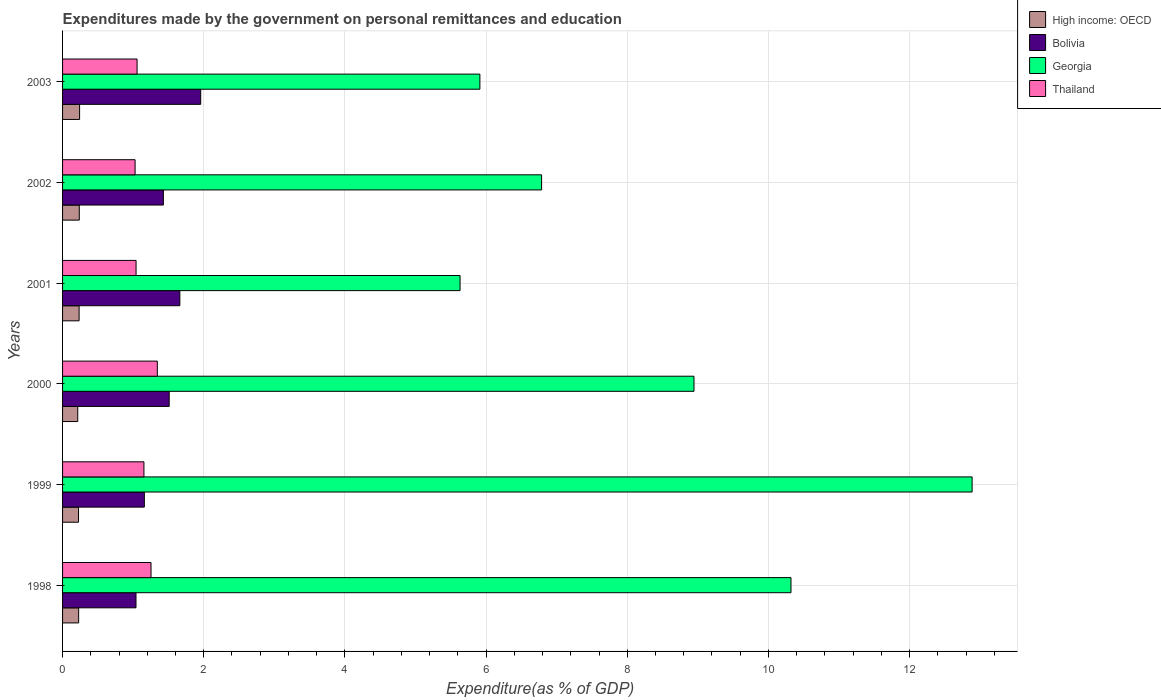How many groups of bars are there?
Make the answer very short. 6. Are the number of bars per tick equal to the number of legend labels?
Provide a succinct answer. Yes. How many bars are there on the 1st tick from the top?
Offer a very short reply. 4. How many bars are there on the 2nd tick from the bottom?
Your answer should be compact. 4. What is the label of the 4th group of bars from the top?
Provide a short and direct response. 2000. In how many cases, is the number of bars for a given year not equal to the number of legend labels?
Your answer should be very brief. 0. What is the expenditures made by the government on personal remittances and education in Bolivia in 2001?
Offer a terse response. 1.66. Across all years, what is the maximum expenditures made by the government on personal remittances and education in Georgia?
Provide a succinct answer. 12.89. Across all years, what is the minimum expenditures made by the government on personal remittances and education in Thailand?
Your answer should be very brief. 1.03. In which year was the expenditures made by the government on personal remittances and education in Bolivia maximum?
Offer a very short reply. 2003. What is the total expenditures made by the government on personal remittances and education in Bolivia in the graph?
Offer a very short reply. 8.76. What is the difference between the expenditures made by the government on personal remittances and education in Georgia in 1998 and that in 2001?
Provide a short and direct response. 4.69. What is the difference between the expenditures made by the government on personal remittances and education in High income: OECD in 2000 and the expenditures made by the government on personal remittances and education in Thailand in 1998?
Offer a terse response. -1.04. What is the average expenditures made by the government on personal remittances and education in Thailand per year?
Your response must be concise. 1.15. In the year 1999, what is the difference between the expenditures made by the government on personal remittances and education in Bolivia and expenditures made by the government on personal remittances and education in High income: OECD?
Your answer should be compact. 0.93. What is the ratio of the expenditures made by the government on personal remittances and education in Georgia in 2002 to that in 2003?
Provide a succinct answer. 1.15. Is the difference between the expenditures made by the government on personal remittances and education in Bolivia in 1998 and 1999 greater than the difference between the expenditures made by the government on personal remittances and education in High income: OECD in 1998 and 1999?
Ensure brevity in your answer.  No. What is the difference between the highest and the second highest expenditures made by the government on personal remittances and education in Georgia?
Ensure brevity in your answer.  2.57. What is the difference between the highest and the lowest expenditures made by the government on personal remittances and education in High income: OECD?
Your answer should be compact. 0.03. Is it the case that in every year, the sum of the expenditures made by the government on personal remittances and education in Thailand and expenditures made by the government on personal remittances and education in High income: OECD is greater than the sum of expenditures made by the government on personal remittances and education in Bolivia and expenditures made by the government on personal remittances and education in Georgia?
Ensure brevity in your answer.  Yes. What does the 3rd bar from the top in 2001 represents?
Offer a terse response. Bolivia. What does the 2nd bar from the bottom in 2000 represents?
Offer a terse response. Bolivia. How many bars are there?
Your answer should be very brief. 24. Are all the bars in the graph horizontal?
Offer a terse response. Yes. How many years are there in the graph?
Offer a very short reply. 6. What is the difference between two consecutive major ticks on the X-axis?
Your answer should be compact. 2. Are the values on the major ticks of X-axis written in scientific E-notation?
Ensure brevity in your answer.  No. Does the graph contain any zero values?
Keep it short and to the point. No. How are the legend labels stacked?
Your answer should be very brief. Vertical. What is the title of the graph?
Ensure brevity in your answer.  Expenditures made by the government on personal remittances and education. What is the label or title of the X-axis?
Offer a very short reply. Expenditure(as % of GDP). What is the Expenditure(as % of GDP) in High income: OECD in 1998?
Offer a terse response. 0.23. What is the Expenditure(as % of GDP) in Bolivia in 1998?
Give a very brief answer. 1.04. What is the Expenditure(as % of GDP) in Georgia in 1998?
Your response must be concise. 10.32. What is the Expenditure(as % of GDP) of Thailand in 1998?
Your answer should be very brief. 1.25. What is the Expenditure(as % of GDP) of High income: OECD in 1999?
Offer a terse response. 0.23. What is the Expenditure(as % of GDP) in Bolivia in 1999?
Make the answer very short. 1.16. What is the Expenditure(as % of GDP) in Georgia in 1999?
Your answer should be very brief. 12.89. What is the Expenditure(as % of GDP) of Thailand in 1999?
Your answer should be compact. 1.15. What is the Expenditure(as % of GDP) of High income: OECD in 2000?
Make the answer very short. 0.22. What is the Expenditure(as % of GDP) of Bolivia in 2000?
Offer a terse response. 1.51. What is the Expenditure(as % of GDP) of Georgia in 2000?
Provide a succinct answer. 8.95. What is the Expenditure(as % of GDP) of Thailand in 2000?
Provide a short and direct response. 1.34. What is the Expenditure(as % of GDP) of High income: OECD in 2001?
Keep it short and to the point. 0.23. What is the Expenditure(as % of GDP) in Bolivia in 2001?
Make the answer very short. 1.66. What is the Expenditure(as % of GDP) in Georgia in 2001?
Ensure brevity in your answer.  5.63. What is the Expenditure(as % of GDP) of Thailand in 2001?
Your answer should be compact. 1.04. What is the Expenditure(as % of GDP) in High income: OECD in 2002?
Offer a terse response. 0.24. What is the Expenditure(as % of GDP) of Bolivia in 2002?
Ensure brevity in your answer.  1.43. What is the Expenditure(as % of GDP) of Georgia in 2002?
Offer a very short reply. 6.79. What is the Expenditure(as % of GDP) of Thailand in 2002?
Provide a succinct answer. 1.03. What is the Expenditure(as % of GDP) of High income: OECD in 2003?
Your answer should be very brief. 0.24. What is the Expenditure(as % of GDP) of Bolivia in 2003?
Keep it short and to the point. 1.96. What is the Expenditure(as % of GDP) of Georgia in 2003?
Your answer should be compact. 5.91. What is the Expenditure(as % of GDP) in Thailand in 2003?
Your answer should be compact. 1.06. Across all years, what is the maximum Expenditure(as % of GDP) in High income: OECD?
Your answer should be very brief. 0.24. Across all years, what is the maximum Expenditure(as % of GDP) in Bolivia?
Your answer should be compact. 1.96. Across all years, what is the maximum Expenditure(as % of GDP) of Georgia?
Provide a succinct answer. 12.89. Across all years, what is the maximum Expenditure(as % of GDP) in Thailand?
Your response must be concise. 1.34. Across all years, what is the minimum Expenditure(as % of GDP) of High income: OECD?
Keep it short and to the point. 0.22. Across all years, what is the minimum Expenditure(as % of GDP) in Bolivia?
Keep it short and to the point. 1.04. Across all years, what is the minimum Expenditure(as % of GDP) of Georgia?
Provide a short and direct response. 5.63. Across all years, what is the minimum Expenditure(as % of GDP) of Thailand?
Make the answer very short. 1.03. What is the total Expenditure(as % of GDP) of High income: OECD in the graph?
Provide a succinct answer. 1.38. What is the total Expenditure(as % of GDP) of Bolivia in the graph?
Ensure brevity in your answer.  8.76. What is the total Expenditure(as % of GDP) of Georgia in the graph?
Offer a very short reply. 50.48. What is the total Expenditure(as % of GDP) in Thailand in the graph?
Offer a terse response. 6.87. What is the difference between the Expenditure(as % of GDP) of High income: OECD in 1998 and that in 1999?
Offer a very short reply. 0. What is the difference between the Expenditure(as % of GDP) of Bolivia in 1998 and that in 1999?
Keep it short and to the point. -0.12. What is the difference between the Expenditure(as % of GDP) of Georgia in 1998 and that in 1999?
Your response must be concise. -2.57. What is the difference between the Expenditure(as % of GDP) in Thailand in 1998 and that in 1999?
Provide a short and direct response. 0.1. What is the difference between the Expenditure(as % of GDP) in High income: OECD in 1998 and that in 2000?
Keep it short and to the point. 0.01. What is the difference between the Expenditure(as % of GDP) in Bolivia in 1998 and that in 2000?
Provide a succinct answer. -0.47. What is the difference between the Expenditure(as % of GDP) in Georgia in 1998 and that in 2000?
Give a very brief answer. 1.37. What is the difference between the Expenditure(as % of GDP) of Thailand in 1998 and that in 2000?
Provide a short and direct response. -0.09. What is the difference between the Expenditure(as % of GDP) of High income: OECD in 1998 and that in 2001?
Provide a succinct answer. -0.01. What is the difference between the Expenditure(as % of GDP) of Bolivia in 1998 and that in 2001?
Offer a terse response. -0.62. What is the difference between the Expenditure(as % of GDP) in Georgia in 1998 and that in 2001?
Offer a terse response. 4.69. What is the difference between the Expenditure(as % of GDP) in Thailand in 1998 and that in 2001?
Provide a short and direct response. 0.21. What is the difference between the Expenditure(as % of GDP) of High income: OECD in 1998 and that in 2002?
Your answer should be compact. -0.01. What is the difference between the Expenditure(as % of GDP) in Bolivia in 1998 and that in 2002?
Ensure brevity in your answer.  -0.39. What is the difference between the Expenditure(as % of GDP) of Georgia in 1998 and that in 2002?
Provide a short and direct response. 3.53. What is the difference between the Expenditure(as % of GDP) of Thailand in 1998 and that in 2002?
Keep it short and to the point. 0.23. What is the difference between the Expenditure(as % of GDP) in High income: OECD in 1998 and that in 2003?
Provide a succinct answer. -0.01. What is the difference between the Expenditure(as % of GDP) of Bolivia in 1998 and that in 2003?
Ensure brevity in your answer.  -0.92. What is the difference between the Expenditure(as % of GDP) of Georgia in 1998 and that in 2003?
Offer a terse response. 4.41. What is the difference between the Expenditure(as % of GDP) in Thailand in 1998 and that in 2003?
Your answer should be very brief. 0.2. What is the difference between the Expenditure(as % of GDP) of High income: OECD in 1999 and that in 2000?
Offer a very short reply. 0.01. What is the difference between the Expenditure(as % of GDP) of Bolivia in 1999 and that in 2000?
Provide a short and direct response. -0.35. What is the difference between the Expenditure(as % of GDP) in Georgia in 1999 and that in 2000?
Offer a very short reply. 3.94. What is the difference between the Expenditure(as % of GDP) of Thailand in 1999 and that in 2000?
Keep it short and to the point. -0.19. What is the difference between the Expenditure(as % of GDP) of High income: OECD in 1999 and that in 2001?
Offer a terse response. -0.01. What is the difference between the Expenditure(as % of GDP) of Bolivia in 1999 and that in 2001?
Offer a very short reply. -0.5. What is the difference between the Expenditure(as % of GDP) in Georgia in 1999 and that in 2001?
Your answer should be very brief. 7.25. What is the difference between the Expenditure(as % of GDP) of Thailand in 1999 and that in 2001?
Your response must be concise. 0.11. What is the difference between the Expenditure(as % of GDP) of High income: OECD in 1999 and that in 2002?
Keep it short and to the point. -0.01. What is the difference between the Expenditure(as % of GDP) of Bolivia in 1999 and that in 2002?
Your answer should be compact. -0.27. What is the difference between the Expenditure(as % of GDP) in Georgia in 1999 and that in 2002?
Make the answer very short. 6.1. What is the difference between the Expenditure(as % of GDP) of Thailand in 1999 and that in 2002?
Your answer should be compact. 0.13. What is the difference between the Expenditure(as % of GDP) in High income: OECD in 1999 and that in 2003?
Offer a very short reply. -0.02. What is the difference between the Expenditure(as % of GDP) of Bolivia in 1999 and that in 2003?
Give a very brief answer. -0.8. What is the difference between the Expenditure(as % of GDP) in Georgia in 1999 and that in 2003?
Your response must be concise. 6.97. What is the difference between the Expenditure(as % of GDP) in Thailand in 1999 and that in 2003?
Your answer should be compact. 0.1. What is the difference between the Expenditure(as % of GDP) of High income: OECD in 2000 and that in 2001?
Make the answer very short. -0.02. What is the difference between the Expenditure(as % of GDP) in Bolivia in 2000 and that in 2001?
Ensure brevity in your answer.  -0.15. What is the difference between the Expenditure(as % of GDP) in Georgia in 2000 and that in 2001?
Your answer should be very brief. 3.31. What is the difference between the Expenditure(as % of GDP) of Thailand in 2000 and that in 2001?
Provide a short and direct response. 0.3. What is the difference between the Expenditure(as % of GDP) of High income: OECD in 2000 and that in 2002?
Your answer should be compact. -0.02. What is the difference between the Expenditure(as % of GDP) of Bolivia in 2000 and that in 2002?
Make the answer very short. 0.08. What is the difference between the Expenditure(as % of GDP) in Georgia in 2000 and that in 2002?
Keep it short and to the point. 2.16. What is the difference between the Expenditure(as % of GDP) of Thailand in 2000 and that in 2002?
Provide a short and direct response. 0.31. What is the difference between the Expenditure(as % of GDP) of High income: OECD in 2000 and that in 2003?
Provide a succinct answer. -0.03. What is the difference between the Expenditure(as % of GDP) in Bolivia in 2000 and that in 2003?
Ensure brevity in your answer.  -0.45. What is the difference between the Expenditure(as % of GDP) in Georgia in 2000 and that in 2003?
Make the answer very short. 3.03. What is the difference between the Expenditure(as % of GDP) of Thailand in 2000 and that in 2003?
Keep it short and to the point. 0.29. What is the difference between the Expenditure(as % of GDP) in High income: OECD in 2001 and that in 2002?
Give a very brief answer. -0. What is the difference between the Expenditure(as % of GDP) in Bolivia in 2001 and that in 2002?
Provide a short and direct response. 0.23. What is the difference between the Expenditure(as % of GDP) of Georgia in 2001 and that in 2002?
Ensure brevity in your answer.  -1.16. What is the difference between the Expenditure(as % of GDP) in Thailand in 2001 and that in 2002?
Ensure brevity in your answer.  0.01. What is the difference between the Expenditure(as % of GDP) of High income: OECD in 2001 and that in 2003?
Your answer should be compact. -0.01. What is the difference between the Expenditure(as % of GDP) in Bolivia in 2001 and that in 2003?
Make the answer very short. -0.3. What is the difference between the Expenditure(as % of GDP) of Georgia in 2001 and that in 2003?
Offer a terse response. -0.28. What is the difference between the Expenditure(as % of GDP) in Thailand in 2001 and that in 2003?
Offer a very short reply. -0.01. What is the difference between the Expenditure(as % of GDP) of High income: OECD in 2002 and that in 2003?
Provide a short and direct response. -0. What is the difference between the Expenditure(as % of GDP) of Bolivia in 2002 and that in 2003?
Give a very brief answer. -0.53. What is the difference between the Expenditure(as % of GDP) of Georgia in 2002 and that in 2003?
Offer a terse response. 0.87. What is the difference between the Expenditure(as % of GDP) in Thailand in 2002 and that in 2003?
Keep it short and to the point. -0.03. What is the difference between the Expenditure(as % of GDP) in High income: OECD in 1998 and the Expenditure(as % of GDP) in Bolivia in 1999?
Offer a terse response. -0.93. What is the difference between the Expenditure(as % of GDP) of High income: OECD in 1998 and the Expenditure(as % of GDP) of Georgia in 1999?
Give a very brief answer. -12.66. What is the difference between the Expenditure(as % of GDP) of High income: OECD in 1998 and the Expenditure(as % of GDP) of Thailand in 1999?
Provide a short and direct response. -0.93. What is the difference between the Expenditure(as % of GDP) in Bolivia in 1998 and the Expenditure(as % of GDP) in Georgia in 1999?
Provide a succinct answer. -11.85. What is the difference between the Expenditure(as % of GDP) of Bolivia in 1998 and the Expenditure(as % of GDP) of Thailand in 1999?
Offer a terse response. -0.11. What is the difference between the Expenditure(as % of GDP) of Georgia in 1998 and the Expenditure(as % of GDP) of Thailand in 1999?
Give a very brief answer. 9.17. What is the difference between the Expenditure(as % of GDP) of High income: OECD in 1998 and the Expenditure(as % of GDP) of Bolivia in 2000?
Your answer should be compact. -1.28. What is the difference between the Expenditure(as % of GDP) in High income: OECD in 1998 and the Expenditure(as % of GDP) in Georgia in 2000?
Keep it short and to the point. -8.72. What is the difference between the Expenditure(as % of GDP) of High income: OECD in 1998 and the Expenditure(as % of GDP) of Thailand in 2000?
Your response must be concise. -1.11. What is the difference between the Expenditure(as % of GDP) of Bolivia in 1998 and the Expenditure(as % of GDP) of Georgia in 2000?
Keep it short and to the point. -7.91. What is the difference between the Expenditure(as % of GDP) of Bolivia in 1998 and the Expenditure(as % of GDP) of Thailand in 2000?
Offer a terse response. -0.3. What is the difference between the Expenditure(as % of GDP) in Georgia in 1998 and the Expenditure(as % of GDP) in Thailand in 2000?
Offer a terse response. 8.98. What is the difference between the Expenditure(as % of GDP) in High income: OECD in 1998 and the Expenditure(as % of GDP) in Bolivia in 2001?
Your response must be concise. -1.43. What is the difference between the Expenditure(as % of GDP) of High income: OECD in 1998 and the Expenditure(as % of GDP) of Georgia in 2001?
Your response must be concise. -5.4. What is the difference between the Expenditure(as % of GDP) of High income: OECD in 1998 and the Expenditure(as % of GDP) of Thailand in 2001?
Your answer should be very brief. -0.81. What is the difference between the Expenditure(as % of GDP) in Bolivia in 1998 and the Expenditure(as % of GDP) in Georgia in 2001?
Give a very brief answer. -4.59. What is the difference between the Expenditure(as % of GDP) in Bolivia in 1998 and the Expenditure(as % of GDP) in Thailand in 2001?
Provide a short and direct response. -0. What is the difference between the Expenditure(as % of GDP) in Georgia in 1998 and the Expenditure(as % of GDP) in Thailand in 2001?
Provide a short and direct response. 9.28. What is the difference between the Expenditure(as % of GDP) in High income: OECD in 1998 and the Expenditure(as % of GDP) in Bolivia in 2002?
Give a very brief answer. -1.2. What is the difference between the Expenditure(as % of GDP) in High income: OECD in 1998 and the Expenditure(as % of GDP) in Georgia in 2002?
Give a very brief answer. -6.56. What is the difference between the Expenditure(as % of GDP) in High income: OECD in 1998 and the Expenditure(as % of GDP) in Thailand in 2002?
Provide a succinct answer. -0.8. What is the difference between the Expenditure(as % of GDP) in Bolivia in 1998 and the Expenditure(as % of GDP) in Georgia in 2002?
Offer a very short reply. -5.75. What is the difference between the Expenditure(as % of GDP) in Bolivia in 1998 and the Expenditure(as % of GDP) in Thailand in 2002?
Make the answer very short. 0.01. What is the difference between the Expenditure(as % of GDP) in Georgia in 1998 and the Expenditure(as % of GDP) in Thailand in 2002?
Offer a very short reply. 9.29. What is the difference between the Expenditure(as % of GDP) of High income: OECD in 1998 and the Expenditure(as % of GDP) of Bolivia in 2003?
Provide a succinct answer. -1.73. What is the difference between the Expenditure(as % of GDP) of High income: OECD in 1998 and the Expenditure(as % of GDP) of Georgia in 2003?
Offer a terse response. -5.68. What is the difference between the Expenditure(as % of GDP) of High income: OECD in 1998 and the Expenditure(as % of GDP) of Thailand in 2003?
Offer a very short reply. -0.83. What is the difference between the Expenditure(as % of GDP) of Bolivia in 1998 and the Expenditure(as % of GDP) of Georgia in 2003?
Provide a succinct answer. -4.87. What is the difference between the Expenditure(as % of GDP) of Bolivia in 1998 and the Expenditure(as % of GDP) of Thailand in 2003?
Keep it short and to the point. -0.02. What is the difference between the Expenditure(as % of GDP) in Georgia in 1998 and the Expenditure(as % of GDP) in Thailand in 2003?
Keep it short and to the point. 9.26. What is the difference between the Expenditure(as % of GDP) of High income: OECD in 1999 and the Expenditure(as % of GDP) of Bolivia in 2000?
Offer a terse response. -1.28. What is the difference between the Expenditure(as % of GDP) of High income: OECD in 1999 and the Expenditure(as % of GDP) of Georgia in 2000?
Make the answer very short. -8.72. What is the difference between the Expenditure(as % of GDP) in High income: OECD in 1999 and the Expenditure(as % of GDP) in Thailand in 2000?
Your response must be concise. -1.12. What is the difference between the Expenditure(as % of GDP) in Bolivia in 1999 and the Expenditure(as % of GDP) in Georgia in 2000?
Provide a short and direct response. -7.79. What is the difference between the Expenditure(as % of GDP) of Bolivia in 1999 and the Expenditure(as % of GDP) of Thailand in 2000?
Keep it short and to the point. -0.18. What is the difference between the Expenditure(as % of GDP) of Georgia in 1999 and the Expenditure(as % of GDP) of Thailand in 2000?
Keep it short and to the point. 11.54. What is the difference between the Expenditure(as % of GDP) of High income: OECD in 1999 and the Expenditure(as % of GDP) of Bolivia in 2001?
Offer a terse response. -1.44. What is the difference between the Expenditure(as % of GDP) in High income: OECD in 1999 and the Expenditure(as % of GDP) in Georgia in 2001?
Give a very brief answer. -5.41. What is the difference between the Expenditure(as % of GDP) of High income: OECD in 1999 and the Expenditure(as % of GDP) of Thailand in 2001?
Your answer should be very brief. -0.82. What is the difference between the Expenditure(as % of GDP) in Bolivia in 1999 and the Expenditure(as % of GDP) in Georgia in 2001?
Offer a terse response. -4.47. What is the difference between the Expenditure(as % of GDP) of Bolivia in 1999 and the Expenditure(as % of GDP) of Thailand in 2001?
Provide a succinct answer. 0.12. What is the difference between the Expenditure(as % of GDP) of Georgia in 1999 and the Expenditure(as % of GDP) of Thailand in 2001?
Offer a very short reply. 11.84. What is the difference between the Expenditure(as % of GDP) in High income: OECD in 1999 and the Expenditure(as % of GDP) in Bolivia in 2002?
Provide a succinct answer. -1.2. What is the difference between the Expenditure(as % of GDP) of High income: OECD in 1999 and the Expenditure(as % of GDP) of Georgia in 2002?
Provide a succinct answer. -6.56. What is the difference between the Expenditure(as % of GDP) of High income: OECD in 1999 and the Expenditure(as % of GDP) of Thailand in 2002?
Keep it short and to the point. -0.8. What is the difference between the Expenditure(as % of GDP) in Bolivia in 1999 and the Expenditure(as % of GDP) in Georgia in 2002?
Your response must be concise. -5.63. What is the difference between the Expenditure(as % of GDP) of Bolivia in 1999 and the Expenditure(as % of GDP) of Thailand in 2002?
Offer a very short reply. 0.13. What is the difference between the Expenditure(as % of GDP) of Georgia in 1999 and the Expenditure(as % of GDP) of Thailand in 2002?
Offer a very short reply. 11.86. What is the difference between the Expenditure(as % of GDP) of High income: OECD in 1999 and the Expenditure(as % of GDP) of Bolivia in 2003?
Your answer should be very brief. -1.73. What is the difference between the Expenditure(as % of GDP) in High income: OECD in 1999 and the Expenditure(as % of GDP) in Georgia in 2003?
Keep it short and to the point. -5.69. What is the difference between the Expenditure(as % of GDP) in High income: OECD in 1999 and the Expenditure(as % of GDP) in Thailand in 2003?
Give a very brief answer. -0.83. What is the difference between the Expenditure(as % of GDP) in Bolivia in 1999 and the Expenditure(as % of GDP) in Georgia in 2003?
Keep it short and to the point. -4.75. What is the difference between the Expenditure(as % of GDP) in Bolivia in 1999 and the Expenditure(as % of GDP) in Thailand in 2003?
Provide a succinct answer. 0.1. What is the difference between the Expenditure(as % of GDP) in Georgia in 1999 and the Expenditure(as % of GDP) in Thailand in 2003?
Make the answer very short. 11.83. What is the difference between the Expenditure(as % of GDP) of High income: OECD in 2000 and the Expenditure(as % of GDP) of Bolivia in 2001?
Your response must be concise. -1.45. What is the difference between the Expenditure(as % of GDP) in High income: OECD in 2000 and the Expenditure(as % of GDP) in Georgia in 2001?
Offer a very short reply. -5.42. What is the difference between the Expenditure(as % of GDP) of High income: OECD in 2000 and the Expenditure(as % of GDP) of Thailand in 2001?
Give a very brief answer. -0.83. What is the difference between the Expenditure(as % of GDP) of Bolivia in 2000 and the Expenditure(as % of GDP) of Georgia in 2001?
Your answer should be compact. -4.12. What is the difference between the Expenditure(as % of GDP) of Bolivia in 2000 and the Expenditure(as % of GDP) of Thailand in 2001?
Provide a short and direct response. 0.47. What is the difference between the Expenditure(as % of GDP) in Georgia in 2000 and the Expenditure(as % of GDP) in Thailand in 2001?
Offer a terse response. 7.9. What is the difference between the Expenditure(as % of GDP) in High income: OECD in 2000 and the Expenditure(as % of GDP) in Bolivia in 2002?
Your answer should be compact. -1.21. What is the difference between the Expenditure(as % of GDP) of High income: OECD in 2000 and the Expenditure(as % of GDP) of Georgia in 2002?
Make the answer very short. -6.57. What is the difference between the Expenditure(as % of GDP) in High income: OECD in 2000 and the Expenditure(as % of GDP) in Thailand in 2002?
Offer a very short reply. -0.81. What is the difference between the Expenditure(as % of GDP) in Bolivia in 2000 and the Expenditure(as % of GDP) in Georgia in 2002?
Keep it short and to the point. -5.28. What is the difference between the Expenditure(as % of GDP) of Bolivia in 2000 and the Expenditure(as % of GDP) of Thailand in 2002?
Provide a short and direct response. 0.48. What is the difference between the Expenditure(as % of GDP) in Georgia in 2000 and the Expenditure(as % of GDP) in Thailand in 2002?
Your answer should be very brief. 7.92. What is the difference between the Expenditure(as % of GDP) of High income: OECD in 2000 and the Expenditure(as % of GDP) of Bolivia in 2003?
Your answer should be very brief. -1.74. What is the difference between the Expenditure(as % of GDP) of High income: OECD in 2000 and the Expenditure(as % of GDP) of Georgia in 2003?
Give a very brief answer. -5.7. What is the difference between the Expenditure(as % of GDP) in High income: OECD in 2000 and the Expenditure(as % of GDP) in Thailand in 2003?
Keep it short and to the point. -0.84. What is the difference between the Expenditure(as % of GDP) of Bolivia in 2000 and the Expenditure(as % of GDP) of Georgia in 2003?
Your response must be concise. -4.4. What is the difference between the Expenditure(as % of GDP) in Bolivia in 2000 and the Expenditure(as % of GDP) in Thailand in 2003?
Provide a short and direct response. 0.46. What is the difference between the Expenditure(as % of GDP) in Georgia in 2000 and the Expenditure(as % of GDP) in Thailand in 2003?
Make the answer very short. 7.89. What is the difference between the Expenditure(as % of GDP) in High income: OECD in 2001 and the Expenditure(as % of GDP) in Bolivia in 2002?
Make the answer very short. -1.19. What is the difference between the Expenditure(as % of GDP) of High income: OECD in 2001 and the Expenditure(as % of GDP) of Georgia in 2002?
Your answer should be compact. -6.55. What is the difference between the Expenditure(as % of GDP) of High income: OECD in 2001 and the Expenditure(as % of GDP) of Thailand in 2002?
Your response must be concise. -0.79. What is the difference between the Expenditure(as % of GDP) of Bolivia in 2001 and the Expenditure(as % of GDP) of Georgia in 2002?
Offer a very short reply. -5.12. What is the difference between the Expenditure(as % of GDP) of Bolivia in 2001 and the Expenditure(as % of GDP) of Thailand in 2002?
Keep it short and to the point. 0.63. What is the difference between the Expenditure(as % of GDP) in Georgia in 2001 and the Expenditure(as % of GDP) in Thailand in 2002?
Your answer should be compact. 4.6. What is the difference between the Expenditure(as % of GDP) in High income: OECD in 2001 and the Expenditure(as % of GDP) in Bolivia in 2003?
Provide a short and direct response. -1.72. What is the difference between the Expenditure(as % of GDP) in High income: OECD in 2001 and the Expenditure(as % of GDP) in Georgia in 2003?
Offer a very short reply. -5.68. What is the difference between the Expenditure(as % of GDP) of High income: OECD in 2001 and the Expenditure(as % of GDP) of Thailand in 2003?
Provide a short and direct response. -0.82. What is the difference between the Expenditure(as % of GDP) in Bolivia in 2001 and the Expenditure(as % of GDP) in Georgia in 2003?
Make the answer very short. -4.25. What is the difference between the Expenditure(as % of GDP) in Bolivia in 2001 and the Expenditure(as % of GDP) in Thailand in 2003?
Your answer should be compact. 0.61. What is the difference between the Expenditure(as % of GDP) in Georgia in 2001 and the Expenditure(as % of GDP) in Thailand in 2003?
Your answer should be very brief. 4.58. What is the difference between the Expenditure(as % of GDP) of High income: OECD in 2002 and the Expenditure(as % of GDP) of Bolivia in 2003?
Keep it short and to the point. -1.72. What is the difference between the Expenditure(as % of GDP) of High income: OECD in 2002 and the Expenditure(as % of GDP) of Georgia in 2003?
Provide a succinct answer. -5.68. What is the difference between the Expenditure(as % of GDP) of High income: OECD in 2002 and the Expenditure(as % of GDP) of Thailand in 2003?
Your answer should be very brief. -0.82. What is the difference between the Expenditure(as % of GDP) of Bolivia in 2002 and the Expenditure(as % of GDP) of Georgia in 2003?
Your answer should be compact. -4.48. What is the difference between the Expenditure(as % of GDP) in Bolivia in 2002 and the Expenditure(as % of GDP) in Thailand in 2003?
Ensure brevity in your answer.  0.37. What is the difference between the Expenditure(as % of GDP) in Georgia in 2002 and the Expenditure(as % of GDP) in Thailand in 2003?
Provide a short and direct response. 5.73. What is the average Expenditure(as % of GDP) of High income: OECD per year?
Your answer should be very brief. 0.23. What is the average Expenditure(as % of GDP) in Bolivia per year?
Offer a terse response. 1.46. What is the average Expenditure(as % of GDP) in Georgia per year?
Ensure brevity in your answer.  8.41. What is the average Expenditure(as % of GDP) in Thailand per year?
Provide a short and direct response. 1.15. In the year 1998, what is the difference between the Expenditure(as % of GDP) of High income: OECD and Expenditure(as % of GDP) of Bolivia?
Make the answer very short. -0.81. In the year 1998, what is the difference between the Expenditure(as % of GDP) in High income: OECD and Expenditure(as % of GDP) in Georgia?
Offer a very short reply. -10.09. In the year 1998, what is the difference between the Expenditure(as % of GDP) in High income: OECD and Expenditure(as % of GDP) in Thailand?
Your answer should be compact. -1.03. In the year 1998, what is the difference between the Expenditure(as % of GDP) of Bolivia and Expenditure(as % of GDP) of Georgia?
Provide a succinct answer. -9.28. In the year 1998, what is the difference between the Expenditure(as % of GDP) in Bolivia and Expenditure(as % of GDP) in Thailand?
Offer a terse response. -0.21. In the year 1998, what is the difference between the Expenditure(as % of GDP) of Georgia and Expenditure(as % of GDP) of Thailand?
Your answer should be compact. 9.07. In the year 1999, what is the difference between the Expenditure(as % of GDP) of High income: OECD and Expenditure(as % of GDP) of Bolivia?
Your response must be concise. -0.93. In the year 1999, what is the difference between the Expenditure(as % of GDP) of High income: OECD and Expenditure(as % of GDP) of Georgia?
Ensure brevity in your answer.  -12.66. In the year 1999, what is the difference between the Expenditure(as % of GDP) of High income: OECD and Expenditure(as % of GDP) of Thailand?
Your answer should be compact. -0.93. In the year 1999, what is the difference between the Expenditure(as % of GDP) of Bolivia and Expenditure(as % of GDP) of Georgia?
Give a very brief answer. -11.73. In the year 1999, what is the difference between the Expenditure(as % of GDP) of Bolivia and Expenditure(as % of GDP) of Thailand?
Provide a short and direct response. 0.01. In the year 1999, what is the difference between the Expenditure(as % of GDP) of Georgia and Expenditure(as % of GDP) of Thailand?
Offer a terse response. 11.73. In the year 2000, what is the difference between the Expenditure(as % of GDP) in High income: OECD and Expenditure(as % of GDP) in Bolivia?
Give a very brief answer. -1.3. In the year 2000, what is the difference between the Expenditure(as % of GDP) in High income: OECD and Expenditure(as % of GDP) in Georgia?
Make the answer very short. -8.73. In the year 2000, what is the difference between the Expenditure(as % of GDP) of High income: OECD and Expenditure(as % of GDP) of Thailand?
Give a very brief answer. -1.13. In the year 2000, what is the difference between the Expenditure(as % of GDP) of Bolivia and Expenditure(as % of GDP) of Georgia?
Your answer should be compact. -7.43. In the year 2000, what is the difference between the Expenditure(as % of GDP) of Bolivia and Expenditure(as % of GDP) of Thailand?
Your response must be concise. 0.17. In the year 2000, what is the difference between the Expenditure(as % of GDP) in Georgia and Expenditure(as % of GDP) in Thailand?
Give a very brief answer. 7.6. In the year 2001, what is the difference between the Expenditure(as % of GDP) in High income: OECD and Expenditure(as % of GDP) in Bolivia?
Your answer should be very brief. -1.43. In the year 2001, what is the difference between the Expenditure(as % of GDP) in High income: OECD and Expenditure(as % of GDP) in Georgia?
Keep it short and to the point. -5.4. In the year 2001, what is the difference between the Expenditure(as % of GDP) of High income: OECD and Expenditure(as % of GDP) of Thailand?
Your response must be concise. -0.81. In the year 2001, what is the difference between the Expenditure(as % of GDP) in Bolivia and Expenditure(as % of GDP) in Georgia?
Ensure brevity in your answer.  -3.97. In the year 2001, what is the difference between the Expenditure(as % of GDP) of Bolivia and Expenditure(as % of GDP) of Thailand?
Offer a terse response. 0.62. In the year 2001, what is the difference between the Expenditure(as % of GDP) in Georgia and Expenditure(as % of GDP) in Thailand?
Ensure brevity in your answer.  4.59. In the year 2002, what is the difference between the Expenditure(as % of GDP) of High income: OECD and Expenditure(as % of GDP) of Bolivia?
Your answer should be compact. -1.19. In the year 2002, what is the difference between the Expenditure(as % of GDP) in High income: OECD and Expenditure(as % of GDP) in Georgia?
Give a very brief answer. -6.55. In the year 2002, what is the difference between the Expenditure(as % of GDP) of High income: OECD and Expenditure(as % of GDP) of Thailand?
Provide a short and direct response. -0.79. In the year 2002, what is the difference between the Expenditure(as % of GDP) of Bolivia and Expenditure(as % of GDP) of Georgia?
Keep it short and to the point. -5.36. In the year 2002, what is the difference between the Expenditure(as % of GDP) in Bolivia and Expenditure(as % of GDP) in Thailand?
Your answer should be compact. 0.4. In the year 2002, what is the difference between the Expenditure(as % of GDP) of Georgia and Expenditure(as % of GDP) of Thailand?
Keep it short and to the point. 5.76. In the year 2003, what is the difference between the Expenditure(as % of GDP) in High income: OECD and Expenditure(as % of GDP) in Bolivia?
Offer a terse response. -1.72. In the year 2003, what is the difference between the Expenditure(as % of GDP) in High income: OECD and Expenditure(as % of GDP) in Georgia?
Your answer should be compact. -5.67. In the year 2003, what is the difference between the Expenditure(as % of GDP) of High income: OECD and Expenditure(as % of GDP) of Thailand?
Provide a short and direct response. -0.81. In the year 2003, what is the difference between the Expenditure(as % of GDP) in Bolivia and Expenditure(as % of GDP) in Georgia?
Keep it short and to the point. -3.96. In the year 2003, what is the difference between the Expenditure(as % of GDP) of Bolivia and Expenditure(as % of GDP) of Thailand?
Keep it short and to the point. 0.9. In the year 2003, what is the difference between the Expenditure(as % of GDP) of Georgia and Expenditure(as % of GDP) of Thailand?
Your answer should be compact. 4.86. What is the ratio of the Expenditure(as % of GDP) of High income: OECD in 1998 to that in 1999?
Your answer should be compact. 1.01. What is the ratio of the Expenditure(as % of GDP) in Bolivia in 1998 to that in 1999?
Ensure brevity in your answer.  0.9. What is the ratio of the Expenditure(as % of GDP) in Georgia in 1998 to that in 1999?
Give a very brief answer. 0.8. What is the ratio of the Expenditure(as % of GDP) of Thailand in 1998 to that in 1999?
Give a very brief answer. 1.09. What is the ratio of the Expenditure(as % of GDP) of High income: OECD in 1998 to that in 2000?
Give a very brief answer. 1.06. What is the ratio of the Expenditure(as % of GDP) in Bolivia in 1998 to that in 2000?
Offer a very short reply. 0.69. What is the ratio of the Expenditure(as % of GDP) of Georgia in 1998 to that in 2000?
Ensure brevity in your answer.  1.15. What is the ratio of the Expenditure(as % of GDP) in Thailand in 1998 to that in 2000?
Provide a succinct answer. 0.93. What is the ratio of the Expenditure(as % of GDP) of High income: OECD in 1998 to that in 2001?
Offer a terse response. 0.97. What is the ratio of the Expenditure(as % of GDP) in Bolivia in 1998 to that in 2001?
Ensure brevity in your answer.  0.63. What is the ratio of the Expenditure(as % of GDP) of Georgia in 1998 to that in 2001?
Offer a very short reply. 1.83. What is the ratio of the Expenditure(as % of GDP) of Thailand in 1998 to that in 2001?
Give a very brief answer. 1.2. What is the ratio of the Expenditure(as % of GDP) in High income: OECD in 1998 to that in 2002?
Ensure brevity in your answer.  0.96. What is the ratio of the Expenditure(as % of GDP) in Bolivia in 1998 to that in 2002?
Offer a very short reply. 0.73. What is the ratio of the Expenditure(as % of GDP) in Georgia in 1998 to that in 2002?
Ensure brevity in your answer.  1.52. What is the ratio of the Expenditure(as % of GDP) in Thailand in 1998 to that in 2002?
Keep it short and to the point. 1.22. What is the ratio of the Expenditure(as % of GDP) of High income: OECD in 1998 to that in 2003?
Offer a very short reply. 0.94. What is the ratio of the Expenditure(as % of GDP) of Bolivia in 1998 to that in 2003?
Make the answer very short. 0.53. What is the ratio of the Expenditure(as % of GDP) in Georgia in 1998 to that in 2003?
Give a very brief answer. 1.75. What is the ratio of the Expenditure(as % of GDP) in Thailand in 1998 to that in 2003?
Offer a very short reply. 1.19. What is the ratio of the Expenditure(as % of GDP) of High income: OECD in 1999 to that in 2000?
Make the answer very short. 1.05. What is the ratio of the Expenditure(as % of GDP) in Bolivia in 1999 to that in 2000?
Your answer should be compact. 0.77. What is the ratio of the Expenditure(as % of GDP) of Georgia in 1999 to that in 2000?
Provide a succinct answer. 1.44. What is the ratio of the Expenditure(as % of GDP) in Thailand in 1999 to that in 2000?
Offer a terse response. 0.86. What is the ratio of the Expenditure(as % of GDP) of High income: OECD in 1999 to that in 2001?
Provide a short and direct response. 0.96. What is the ratio of the Expenditure(as % of GDP) of Bolivia in 1999 to that in 2001?
Offer a very short reply. 0.7. What is the ratio of the Expenditure(as % of GDP) of Georgia in 1999 to that in 2001?
Keep it short and to the point. 2.29. What is the ratio of the Expenditure(as % of GDP) of Thailand in 1999 to that in 2001?
Provide a short and direct response. 1.11. What is the ratio of the Expenditure(as % of GDP) in High income: OECD in 1999 to that in 2002?
Offer a very short reply. 0.95. What is the ratio of the Expenditure(as % of GDP) of Bolivia in 1999 to that in 2002?
Your response must be concise. 0.81. What is the ratio of the Expenditure(as % of GDP) in Georgia in 1999 to that in 2002?
Your response must be concise. 1.9. What is the ratio of the Expenditure(as % of GDP) of Thailand in 1999 to that in 2002?
Provide a short and direct response. 1.12. What is the ratio of the Expenditure(as % of GDP) in High income: OECD in 1999 to that in 2003?
Your answer should be very brief. 0.94. What is the ratio of the Expenditure(as % of GDP) in Bolivia in 1999 to that in 2003?
Offer a very short reply. 0.59. What is the ratio of the Expenditure(as % of GDP) in Georgia in 1999 to that in 2003?
Provide a succinct answer. 2.18. What is the ratio of the Expenditure(as % of GDP) in Thailand in 1999 to that in 2003?
Ensure brevity in your answer.  1.09. What is the ratio of the Expenditure(as % of GDP) of High income: OECD in 2000 to that in 2001?
Make the answer very short. 0.92. What is the ratio of the Expenditure(as % of GDP) in Bolivia in 2000 to that in 2001?
Offer a very short reply. 0.91. What is the ratio of the Expenditure(as % of GDP) of Georgia in 2000 to that in 2001?
Offer a terse response. 1.59. What is the ratio of the Expenditure(as % of GDP) of Thailand in 2000 to that in 2001?
Your answer should be compact. 1.29. What is the ratio of the Expenditure(as % of GDP) of High income: OECD in 2000 to that in 2002?
Your response must be concise. 0.91. What is the ratio of the Expenditure(as % of GDP) of Bolivia in 2000 to that in 2002?
Offer a very short reply. 1.06. What is the ratio of the Expenditure(as % of GDP) of Georgia in 2000 to that in 2002?
Your response must be concise. 1.32. What is the ratio of the Expenditure(as % of GDP) in Thailand in 2000 to that in 2002?
Your response must be concise. 1.31. What is the ratio of the Expenditure(as % of GDP) in High income: OECD in 2000 to that in 2003?
Your answer should be compact. 0.89. What is the ratio of the Expenditure(as % of GDP) in Bolivia in 2000 to that in 2003?
Provide a short and direct response. 0.77. What is the ratio of the Expenditure(as % of GDP) of Georgia in 2000 to that in 2003?
Provide a short and direct response. 1.51. What is the ratio of the Expenditure(as % of GDP) of Thailand in 2000 to that in 2003?
Give a very brief answer. 1.27. What is the ratio of the Expenditure(as % of GDP) in High income: OECD in 2001 to that in 2002?
Your response must be concise. 0.99. What is the ratio of the Expenditure(as % of GDP) in Bolivia in 2001 to that in 2002?
Make the answer very short. 1.16. What is the ratio of the Expenditure(as % of GDP) in Georgia in 2001 to that in 2002?
Provide a short and direct response. 0.83. What is the ratio of the Expenditure(as % of GDP) in Thailand in 2001 to that in 2002?
Your answer should be very brief. 1.01. What is the ratio of the Expenditure(as % of GDP) of High income: OECD in 2001 to that in 2003?
Your answer should be very brief. 0.97. What is the ratio of the Expenditure(as % of GDP) in Bolivia in 2001 to that in 2003?
Provide a short and direct response. 0.85. What is the ratio of the Expenditure(as % of GDP) of Georgia in 2001 to that in 2003?
Offer a very short reply. 0.95. What is the ratio of the Expenditure(as % of GDP) of Thailand in 2001 to that in 2003?
Your answer should be compact. 0.99. What is the ratio of the Expenditure(as % of GDP) in High income: OECD in 2002 to that in 2003?
Provide a succinct answer. 0.98. What is the ratio of the Expenditure(as % of GDP) in Bolivia in 2002 to that in 2003?
Provide a short and direct response. 0.73. What is the ratio of the Expenditure(as % of GDP) of Georgia in 2002 to that in 2003?
Make the answer very short. 1.15. What is the ratio of the Expenditure(as % of GDP) of Thailand in 2002 to that in 2003?
Your answer should be very brief. 0.97. What is the difference between the highest and the second highest Expenditure(as % of GDP) of High income: OECD?
Your answer should be very brief. 0. What is the difference between the highest and the second highest Expenditure(as % of GDP) in Bolivia?
Ensure brevity in your answer.  0.3. What is the difference between the highest and the second highest Expenditure(as % of GDP) of Georgia?
Ensure brevity in your answer.  2.57. What is the difference between the highest and the second highest Expenditure(as % of GDP) in Thailand?
Offer a terse response. 0.09. What is the difference between the highest and the lowest Expenditure(as % of GDP) of High income: OECD?
Your response must be concise. 0.03. What is the difference between the highest and the lowest Expenditure(as % of GDP) of Bolivia?
Provide a short and direct response. 0.92. What is the difference between the highest and the lowest Expenditure(as % of GDP) in Georgia?
Offer a terse response. 7.25. What is the difference between the highest and the lowest Expenditure(as % of GDP) in Thailand?
Your response must be concise. 0.31. 